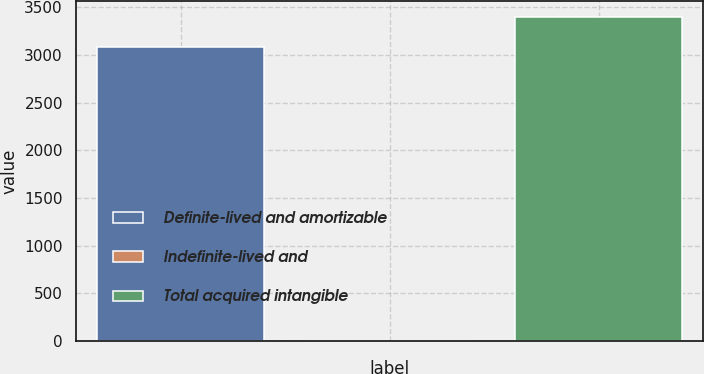Convert chart to OTSL. <chart><loc_0><loc_0><loc_500><loc_500><bar_chart><fcel>Definite-lived and amortizable<fcel>Indefinite-lived and<fcel>Total acquired intangible<nl><fcel>3085<fcel>2.03<fcel>3393.3<nl></chart> 